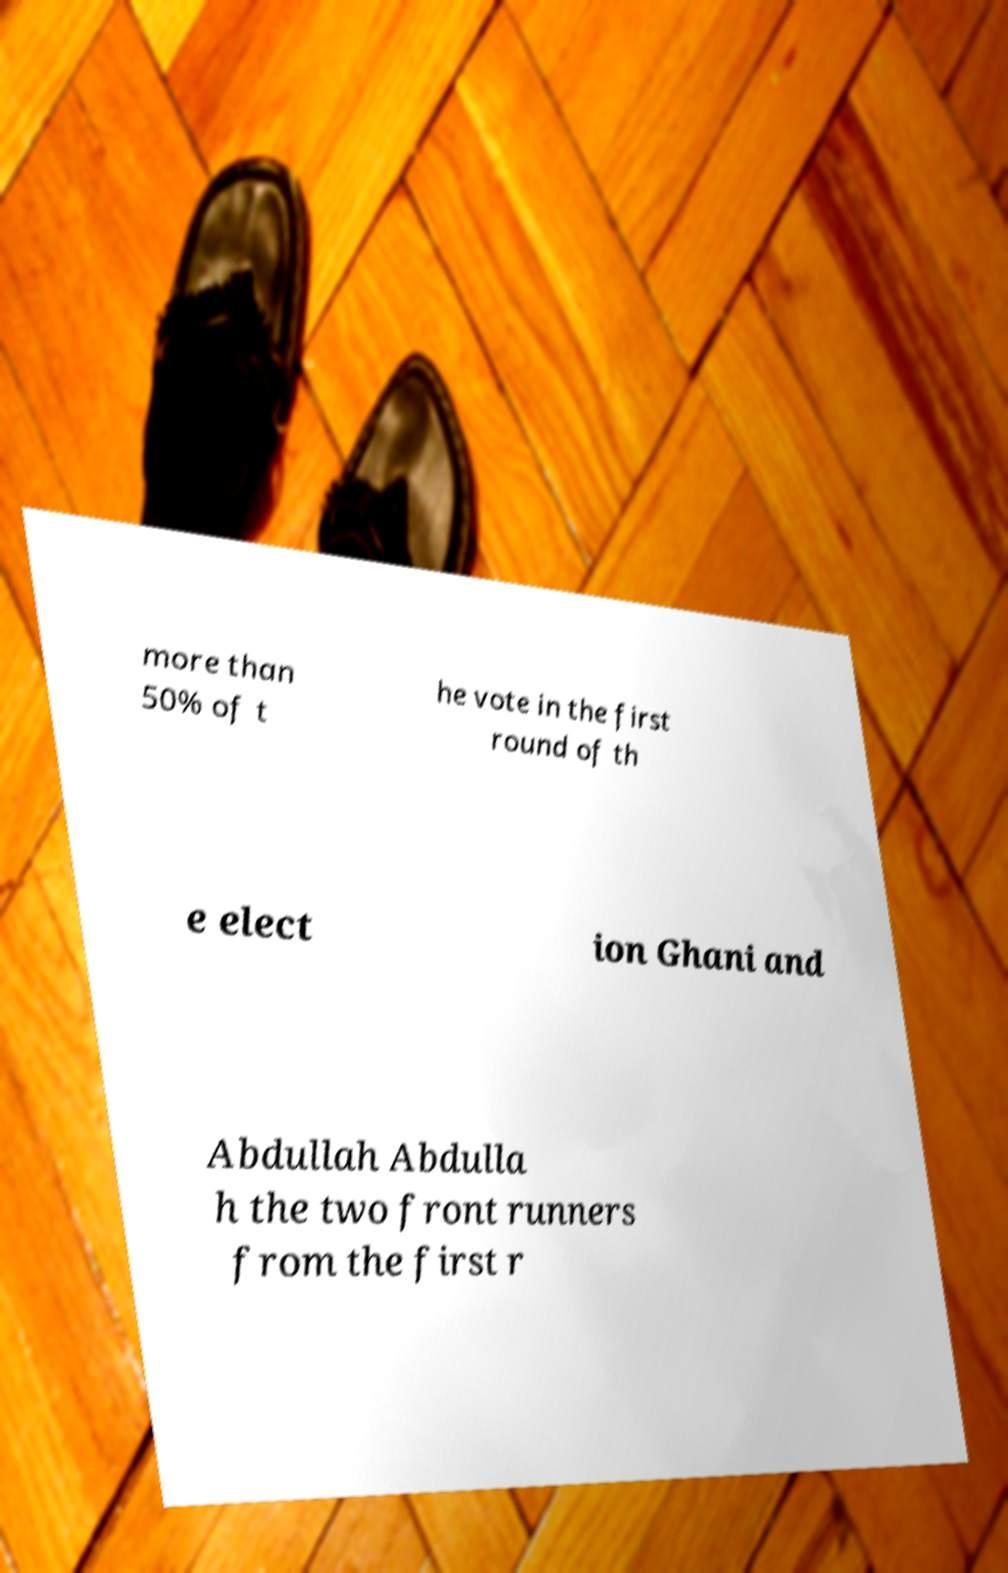What messages or text are displayed in this image? I need them in a readable, typed format. more than 50% of t he vote in the first round of th e elect ion Ghani and Abdullah Abdulla h the two front runners from the first r 